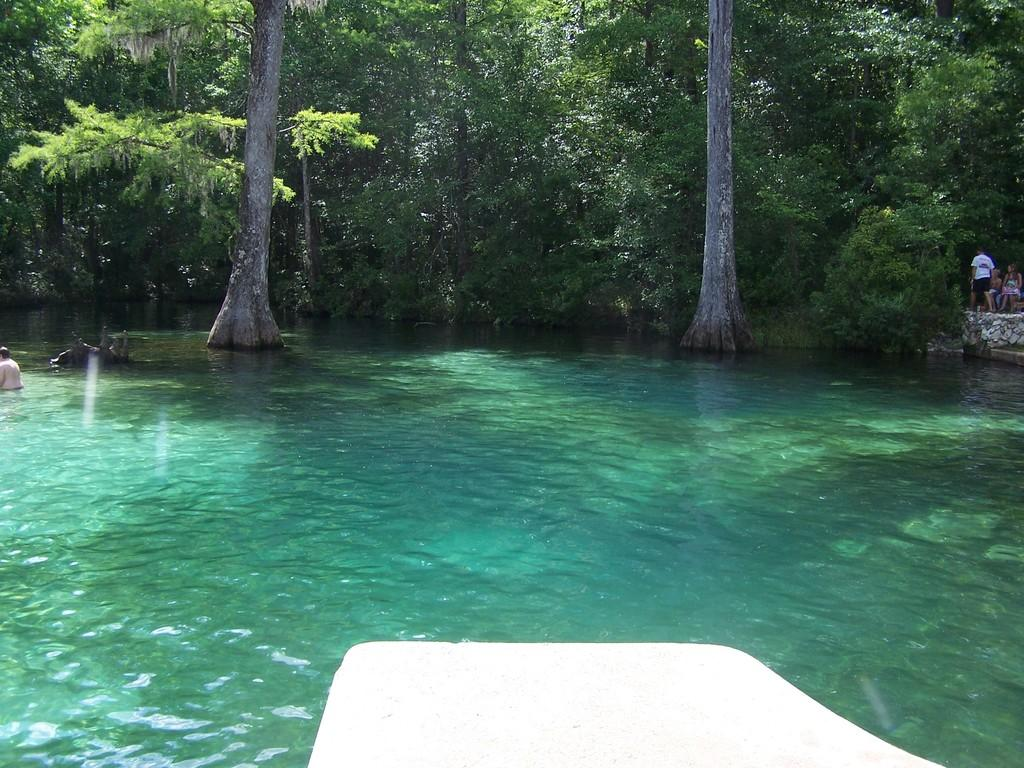What are the people in the image doing? The people in the image are swimming in a water body. What can be seen in the background of the image? There are trees visible in the background. Are there any other people in the image besides the ones swimming? Yes, there are people in the background. What type of root can be seen growing in the water body? There is no root visible in the water body; the image only shows people swimming. 